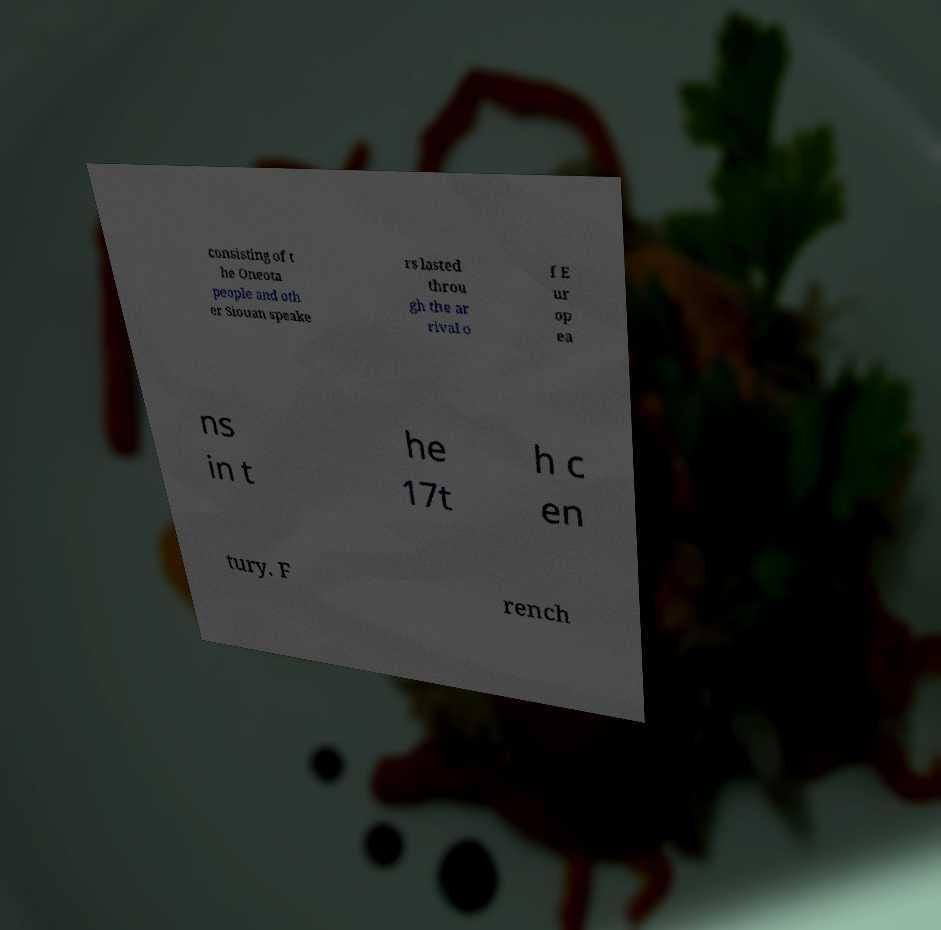Could you assist in decoding the text presented in this image and type it out clearly? consisting of t he Oneota people and oth er Siouan speake rs lasted throu gh the ar rival o f E ur op ea ns in t he 17t h c en tury. F rench 